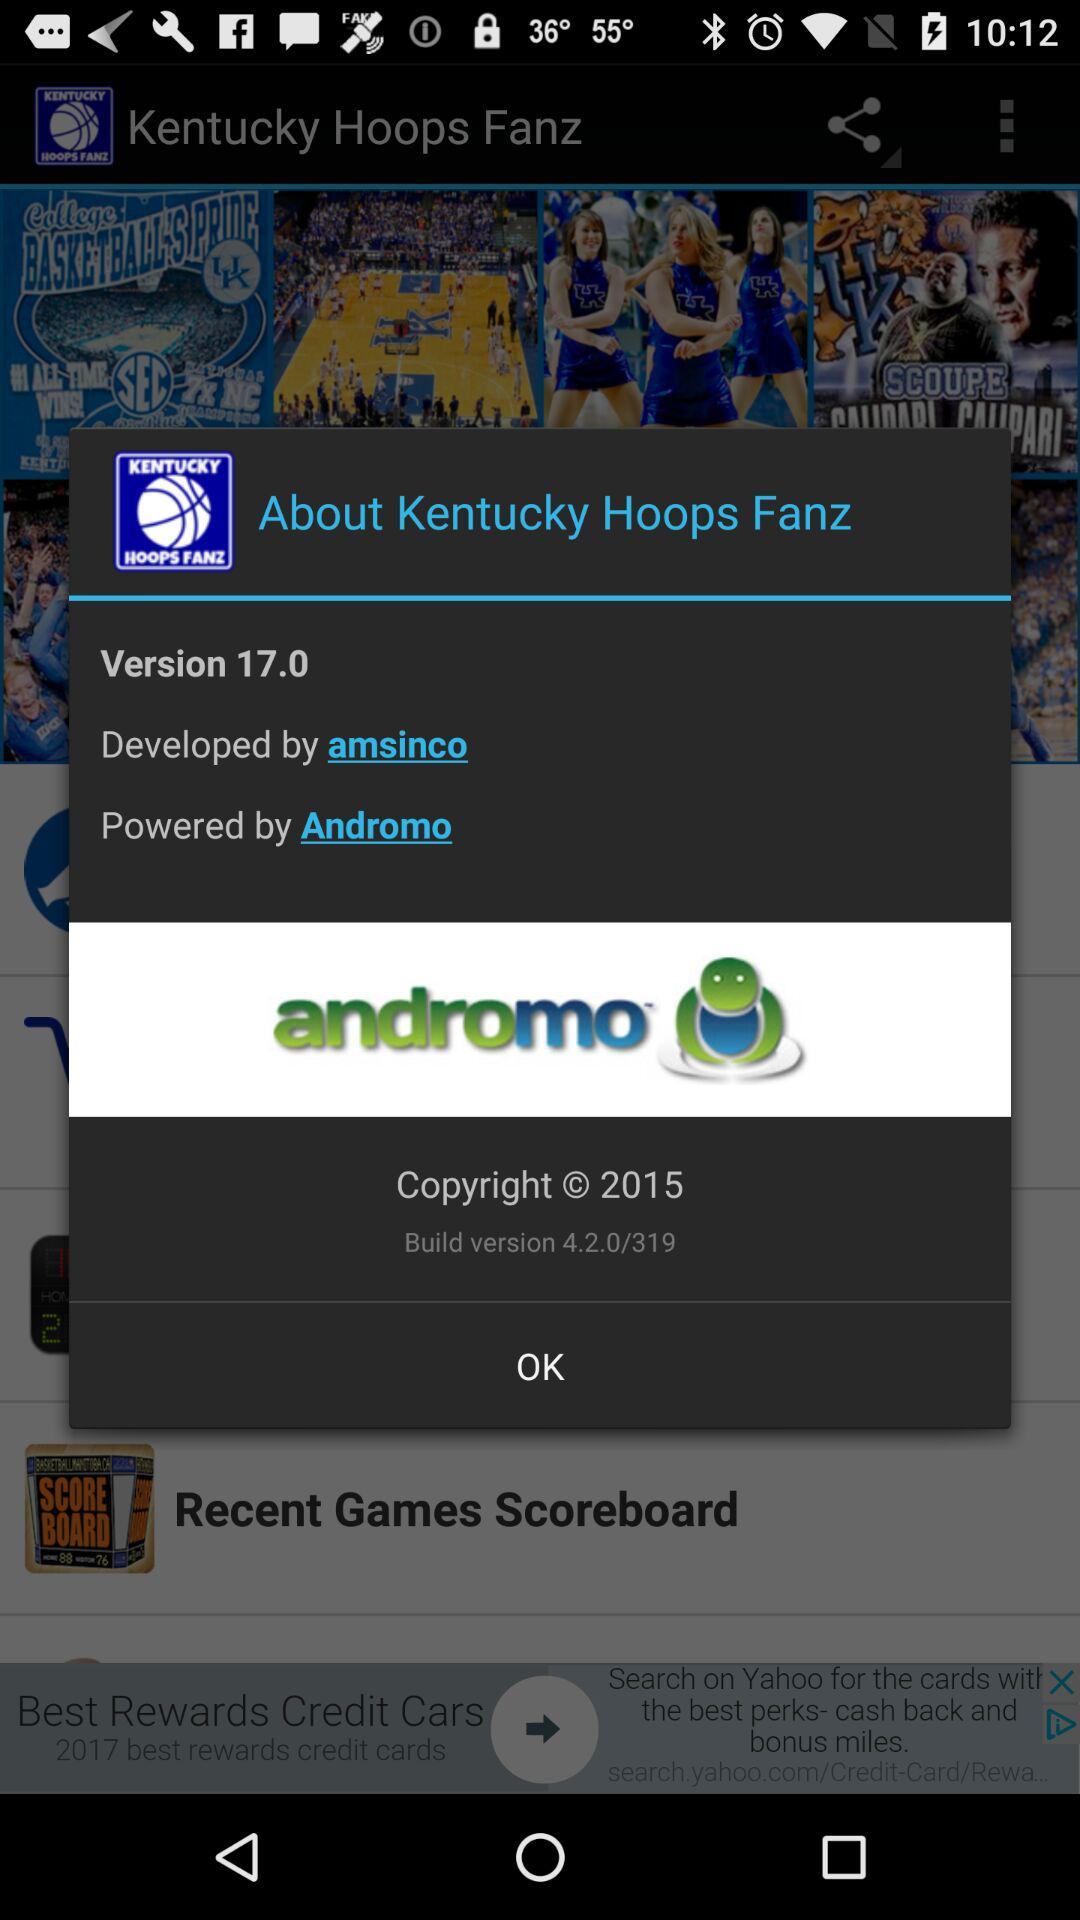Which version is used? The used version is 17.0. 